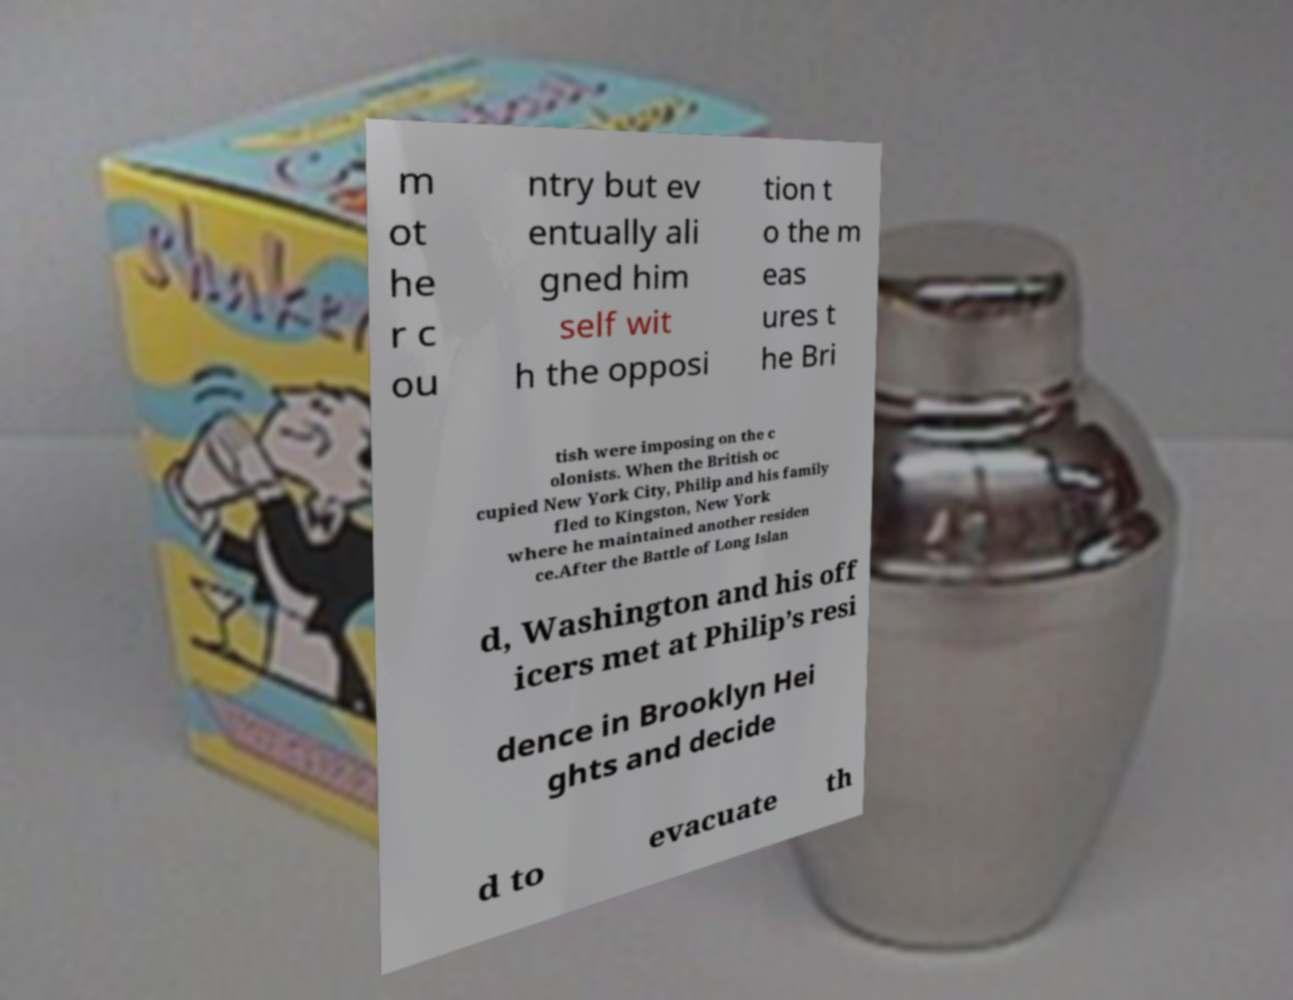Can you read and provide the text displayed in the image?This photo seems to have some interesting text. Can you extract and type it out for me? m ot he r c ou ntry but ev entually ali gned him self wit h the opposi tion t o the m eas ures t he Bri tish were imposing on the c olonists. When the British oc cupied New York City, Philip and his family fled to Kingston, New York where he maintained another residen ce.After the Battle of Long Islan d, Washington and his off icers met at Philip’s resi dence in Brooklyn Hei ghts and decide d to evacuate th 